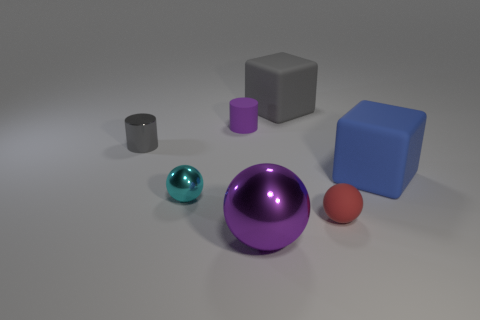Add 1 green shiny spheres. How many objects exist? 8 Subtract all blocks. How many objects are left? 5 Add 7 cyan metal balls. How many cyan metal balls exist? 8 Subtract 0 green balls. How many objects are left? 7 Subtract all purple balls. Subtract all red matte spheres. How many objects are left? 5 Add 5 tiny purple rubber cylinders. How many tiny purple rubber cylinders are left? 6 